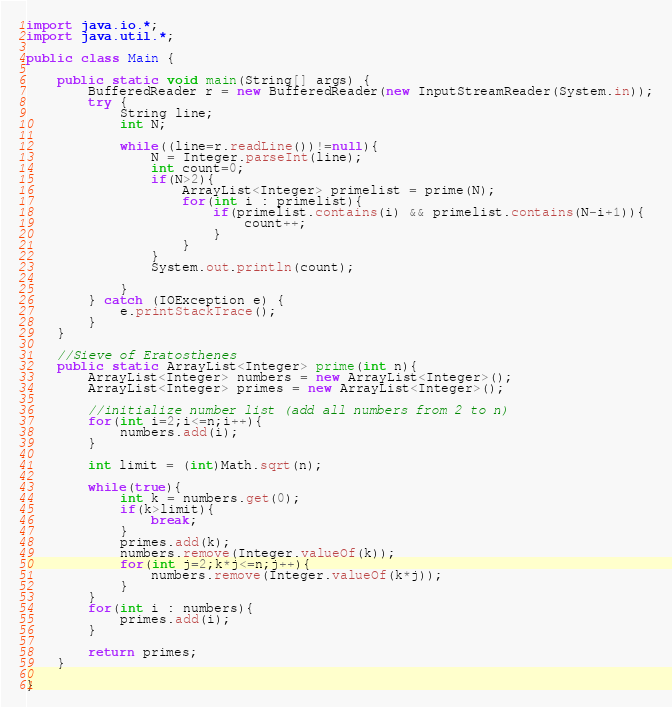<code> <loc_0><loc_0><loc_500><loc_500><_Java_>import java.io.*;
import java.util.*;

public class Main {

	public static void main(String[] args) {
		BufferedReader r = new BufferedReader(new InputStreamReader(System.in));
		try {
			String line;
			int N;
			
			while((line=r.readLine())!=null){
				N = Integer.parseInt(line);
				int count=0;
				if(N>2){
					ArrayList<Integer> primelist = prime(N);
					for(int i : primelist){
						if(primelist.contains(i) && primelist.contains(N-i+1)){
							count++;
						}
					}
				}
				System.out.println(count);
				
			}
		} catch (IOException e) {
			e.printStackTrace();
		}
	}
	
	//Sieve of Eratosthenes
	public static ArrayList<Integer> prime(int n){
		ArrayList<Integer> numbers = new ArrayList<Integer>();
		ArrayList<Integer> primes = new ArrayList<Integer>();
		
		//initialize number list (add all numbers from 2 to n)
		for(int i=2;i<=n;i++){
			numbers.add(i);
		}
		
		int limit = (int)Math.sqrt(n);
		
		while(true){
			int k = numbers.get(0);
			if(k>limit){
				break;
			}
			primes.add(k);
			numbers.remove(Integer.valueOf(k));
			for(int j=2;k*j<=n;j++){
				numbers.remove(Integer.valueOf(k*j));
			}
		}
		for(int i : numbers){
			primes.add(i);
		}
		
		return primes;
	}
	
}</code> 